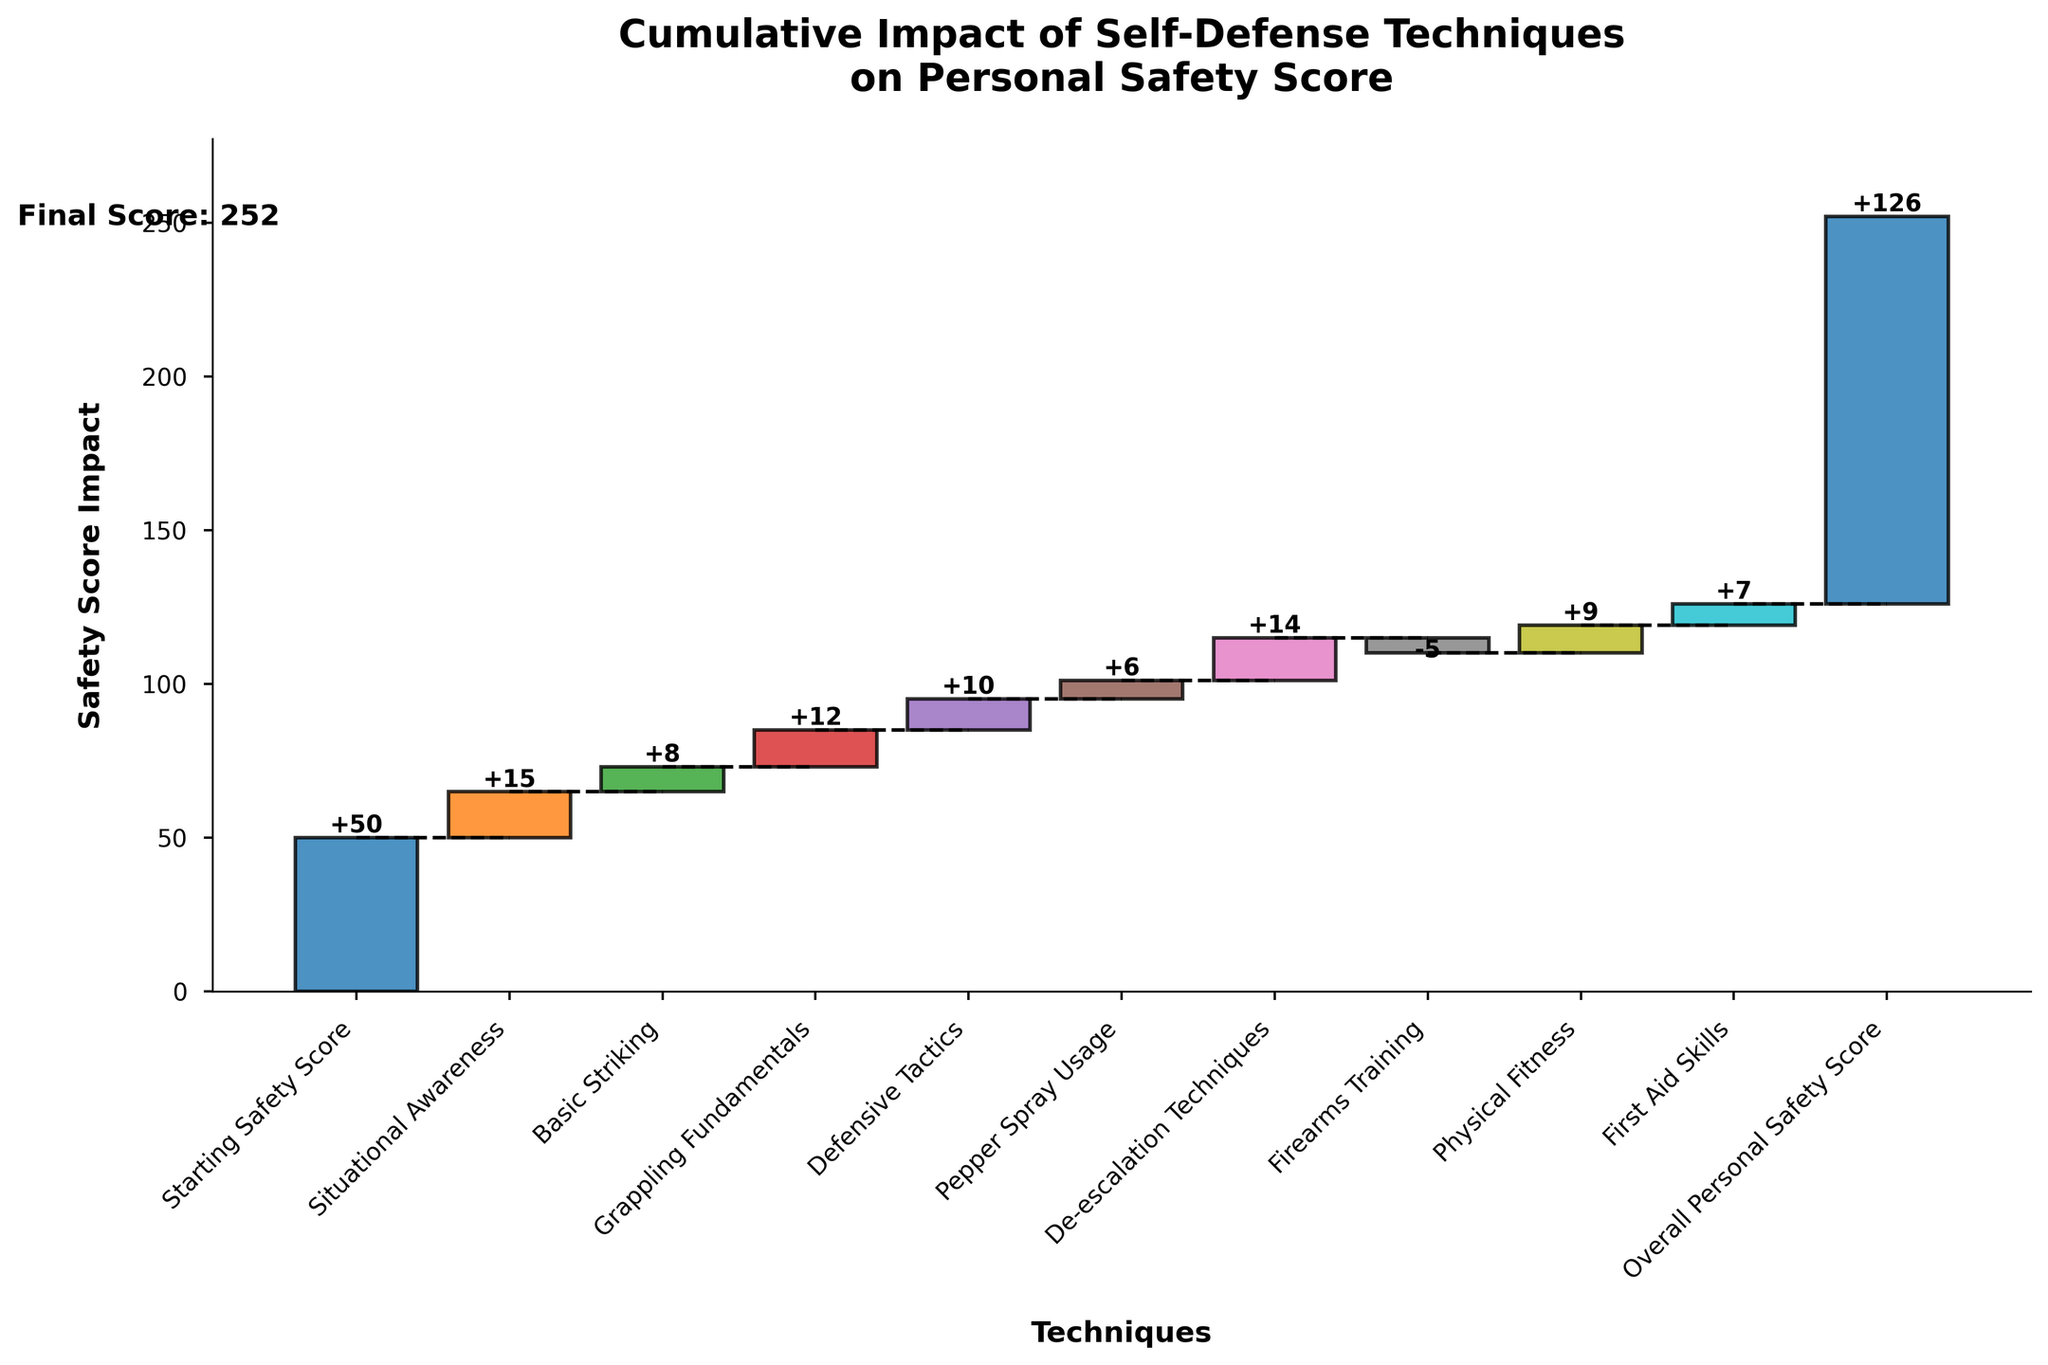What's the title of the chart? The title of the chart is displayed at the top and is intended to convey the main message of the visual. Here it clearly states, "Cumulative Impact of Self-Defense Techniques on Personal Safety Score."
Answer: Cumulative Impact of Self-Defense Techniques on Personal Safety Score Which technique has the highest positive impact on the safety score? To find the highest positive impact, look for the technique with the tallest bar pointing upwards. De-escalation Techniques stands out with an impact of +14.
Answer: De-escalation Techniques What's the final personal safety score? The final personal safety score is shown at the end of the cumulative bars and is explicitly labeled in the graph. It indicates the overall improvement after considering all impacts.
Answer: 126 How does firearms training affect the personal safety score? To determine the effect of firearms training, locate the bar for Firearms Training. This bar is negative and decreases the cumulative score, showing an impact of -5.
Answer: -5 Compare the impacts of Basic Striking and Grappling Fundamentals. Which one contributes more to the safety score? Look at the heights of the bars for Basic Striking and Grappling Fundamentals. Basic Striking has an impact of +8, while Grappling Fundamentals contributes +12. Hence, Grappling Fundamentals has a more significant impact.
Answer: Grappling Fundamentals What cumulative score is achieved after Situational Awareness and Basic Striking techniques? The cumulative score after these two techniques combines their individual impacts starting from the initial score. So, 50 (initial) + 15 (Situational Awareness) + 8 (Basic Striking) = 73.
Answer: 73 Which technique immediately follows Grappling Fundamentals in the chart, and what is its impact? After Grappling Fundamentals, the next technique is Defensive Tactics. By visually scanning the chart, its impact is observed to be +10.
Answer: Defensive Tactics, +10 What is the cumulative score after Physical Fitness? The cumulative score is the value at the end of the bar representing Physical Fitness. By adding the impacts sequentially up to this technique, the score is 50 + 15 + 8 + 12 + 10 + 6 + 14 - 5 + 9 = 119.
Answer: 119 Is the impact of First Aid Skills higher or lower than that of Pepper Spray Usage? Compare the bar heights of First Aid Skills and Pepper Spray Usage. First Aid Skills has an impact of +7, whereas Pepper Spray Usage has +6. Hence, First Aid Skills has a higher impact.
Answer: Higher Calculate the total positive impact of all the techniques, excluding the starting and final scores. Sum all the positive impacts: 15 (Situational Awareness) + 8 (Basic Striking) + 12 (Grappling Fundamentals) + 10 (Defensive Tactics) + 6 (Pepper Spray Usage) + 14 (De-escalation Techniques) + 9 (Physical Fitness) + 7 (First Aid Skills) = 81.
Answer: 81 